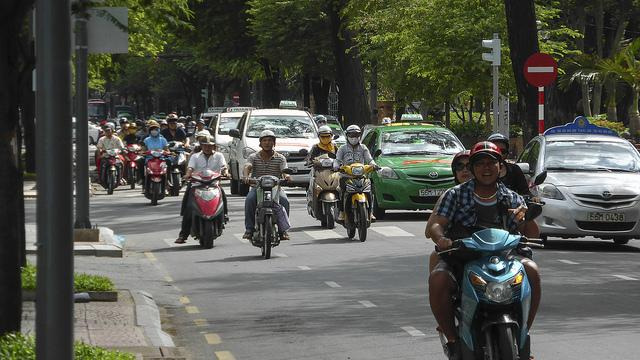How many directions does traffic flow in these pictured lanes? one 